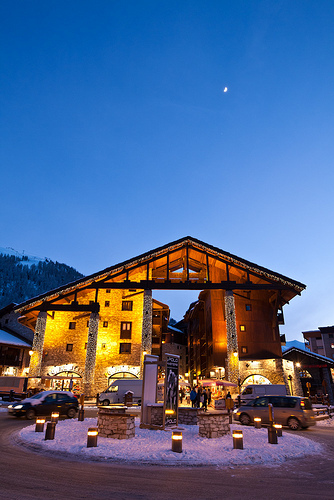<image>
Can you confirm if the moutain is behind the cabin? Yes. From this viewpoint, the moutain is positioned behind the cabin, with the cabin partially or fully occluding the moutain. 